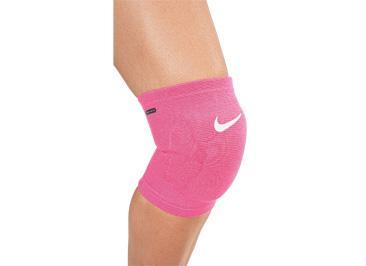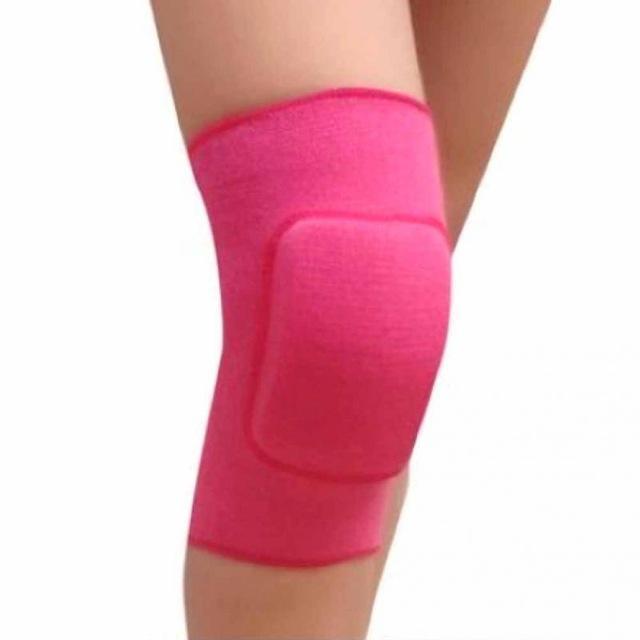The first image is the image on the left, the second image is the image on the right. Evaluate the accuracy of this statement regarding the images: "Each image includes a rightward-bent knee in a hot pink knee pad.". Is it true? Answer yes or no. Yes. 